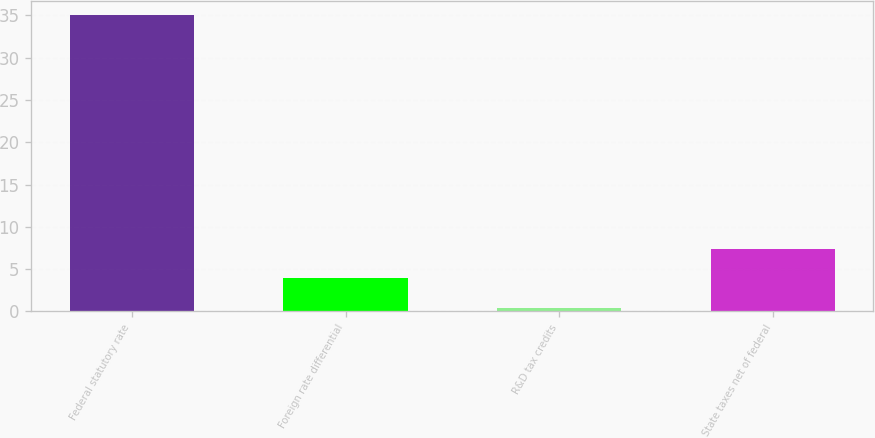<chart> <loc_0><loc_0><loc_500><loc_500><bar_chart><fcel>Federal statutory rate<fcel>Foreign rate differential<fcel>R&D tax credits<fcel>State taxes net of federal<nl><fcel>35<fcel>3.91<fcel>0.45<fcel>7.37<nl></chart> 